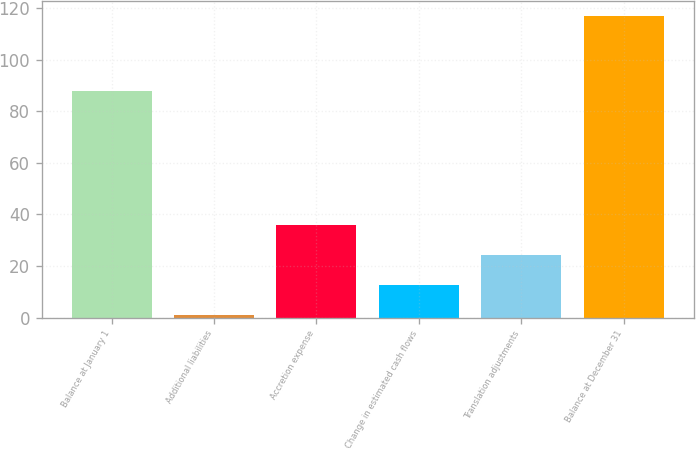Convert chart to OTSL. <chart><loc_0><loc_0><loc_500><loc_500><bar_chart><fcel>Balance at January 1<fcel>Additional liabilities<fcel>Accretion expense<fcel>Change in estimated cash flows<fcel>Translation adjustments<fcel>Balance at December 31<nl><fcel>88<fcel>1<fcel>35.8<fcel>12.6<fcel>24.2<fcel>117<nl></chart> 